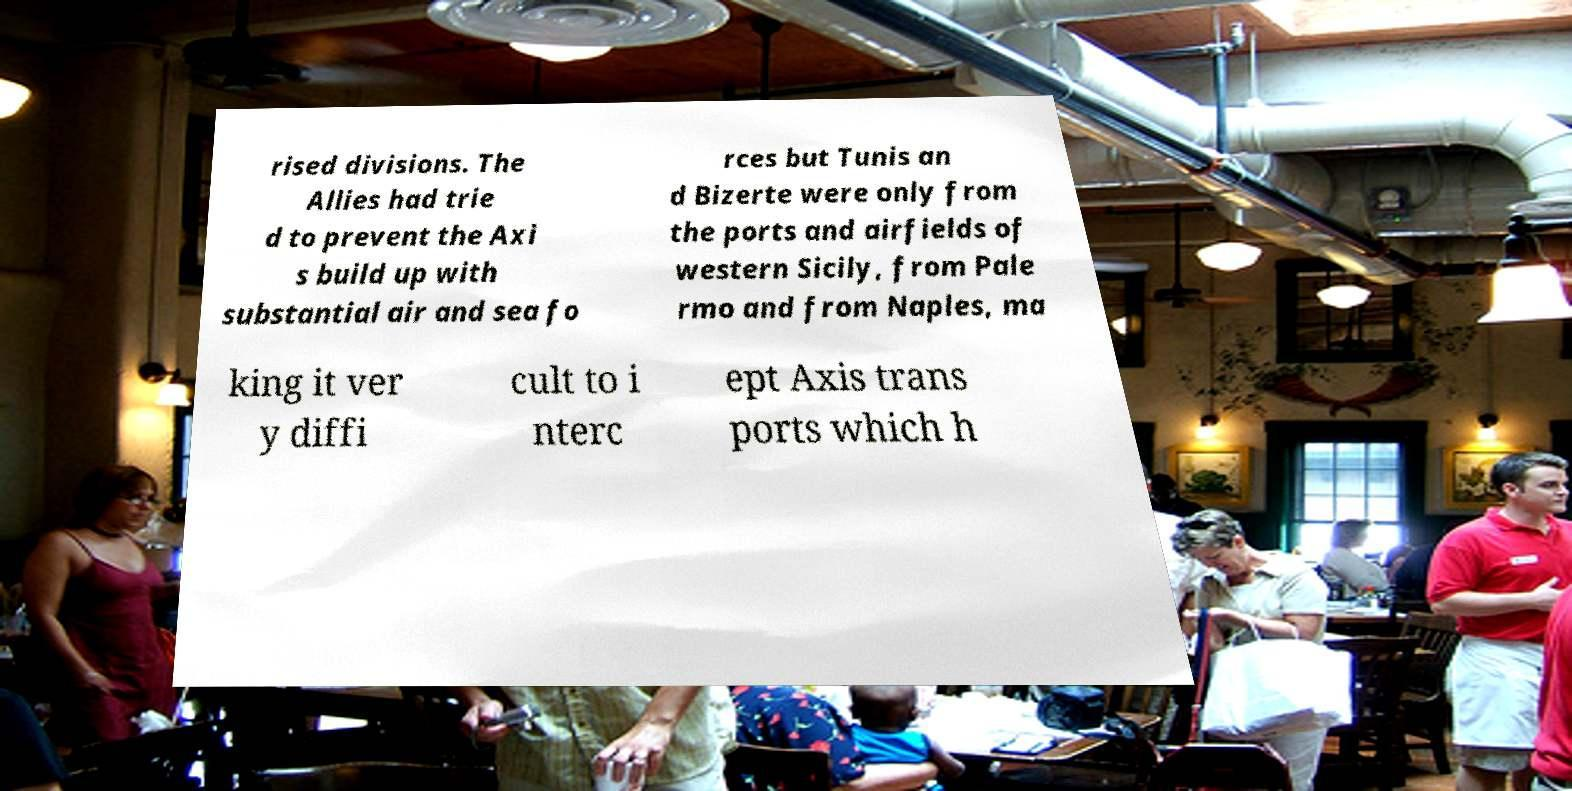Could you extract and type out the text from this image? rised divisions. The Allies had trie d to prevent the Axi s build up with substantial air and sea fo rces but Tunis an d Bizerte were only from the ports and airfields of western Sicily, from Pale rmo and from Naples, ma king it ver y diffi cult to i nterc ept Axis trans ports which h 